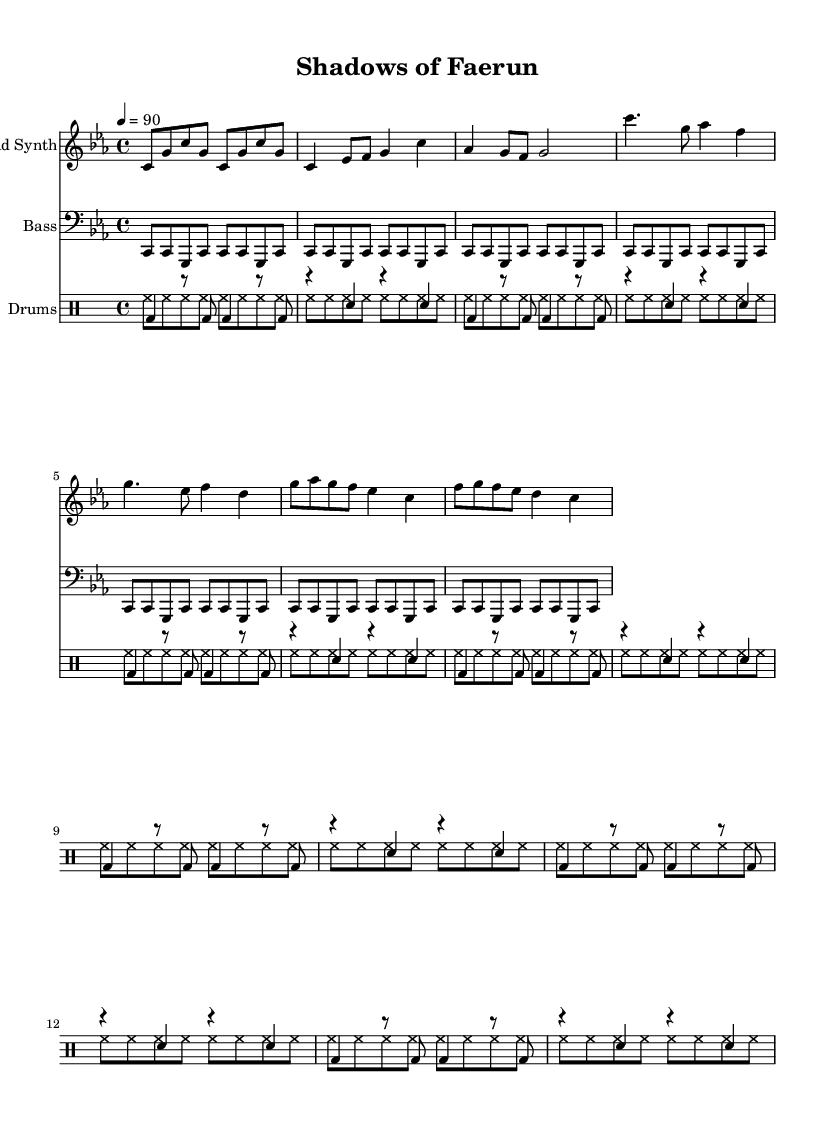What is the time signature of this music? The time signature is indicated at the beginning of the score as 4/4, meaning there are four beats in each measure and the quarter note gets one beat.
Answer: 4/4 What is the key signature of this music? The key signature shows C minor, which has three flats (B flat, E flat, and A flat). It's identifiable by the flat symbols at the beginning of the staff.
Answer: C minor What is the tempo marking of this music? The tempo marking is found near the top and indicates the beats per minute, set to 90 in this case, which dictates the pace of the piece.
Answer: 90 What is the structure of the piece in terms of sections? The piece consists of an Intro, Verse, Chorus, and Bridge, distinguished by musical content and transitions between them.
Answer: Intro, Verse, Chorus, Bridge How many times is the main bass line repeated? The bass line is visually indicated by the repeat sign in the bass clef, which shows that the line is repeated seven times in total.
Answer: 7 What type of rhythm is predominantly used in the drums section? The drums feature a combination of bass drum and snare drum patterns, using both pitched and unpitched drums, indicative of a typical hip-hop beat structure.
Answer: Hip-hop beat What themes do the lyrics in this music explore? Although the sheet music does not contain lyrics, the title "Shadows of Faerun" suggests themes of character development and moral choices, typical of a narrative-driven hip-hop track.
Answer: Character development and moral choices 